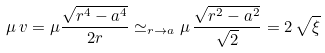<formula> <loc_0><loc_0><loc_500><loc_500>\mu \, v = \mu \frac { \sqrt { r ^ { 4 } - a ^ { 4 } } } { 2 r } \simeq _ { r \to a } \mu \, \frac { \sqrt { r ^ { 2 } - a ^ { 2 } } } { \sqrt { 2 } } = 2 \, \sqrt { \xi }</formula> 